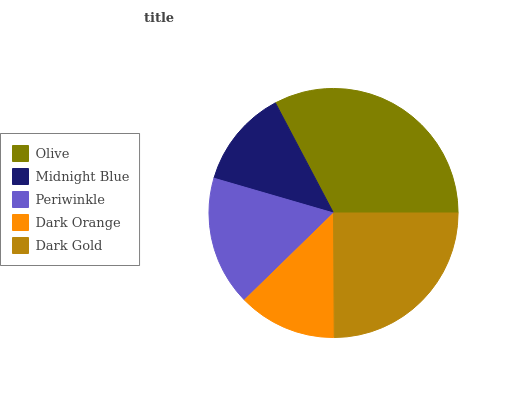Is Midnight Blue the minimum?
Answer yes or no. Yes. Is Olive the maximum?
Answer yes or no. Yes. Is Periwinkle the minimum?
Answer yes or no. No. Is Periwinkle the maximum?
Answer yes or no. No. Is Periwinkle greater than Midnight Blue?
Answer yes or no. Yes. Is Midnight Blue less than Periwinkle?
Answer yes or no. Yes. Is Midnight Blue greater than Periwinkle?
Answer yes or no. No. Is Periwinkle less than Midnight Blue?
Answer yes or no. No. Is Periwinkle the high median?
Answer yes or no. Yes. Is Periwinkle the low median?
Answer yes or no. Yes. Is Olive the high median?
Answer yes or no. No. Is Dark Orange the low median?
Answer yes or no. No. 